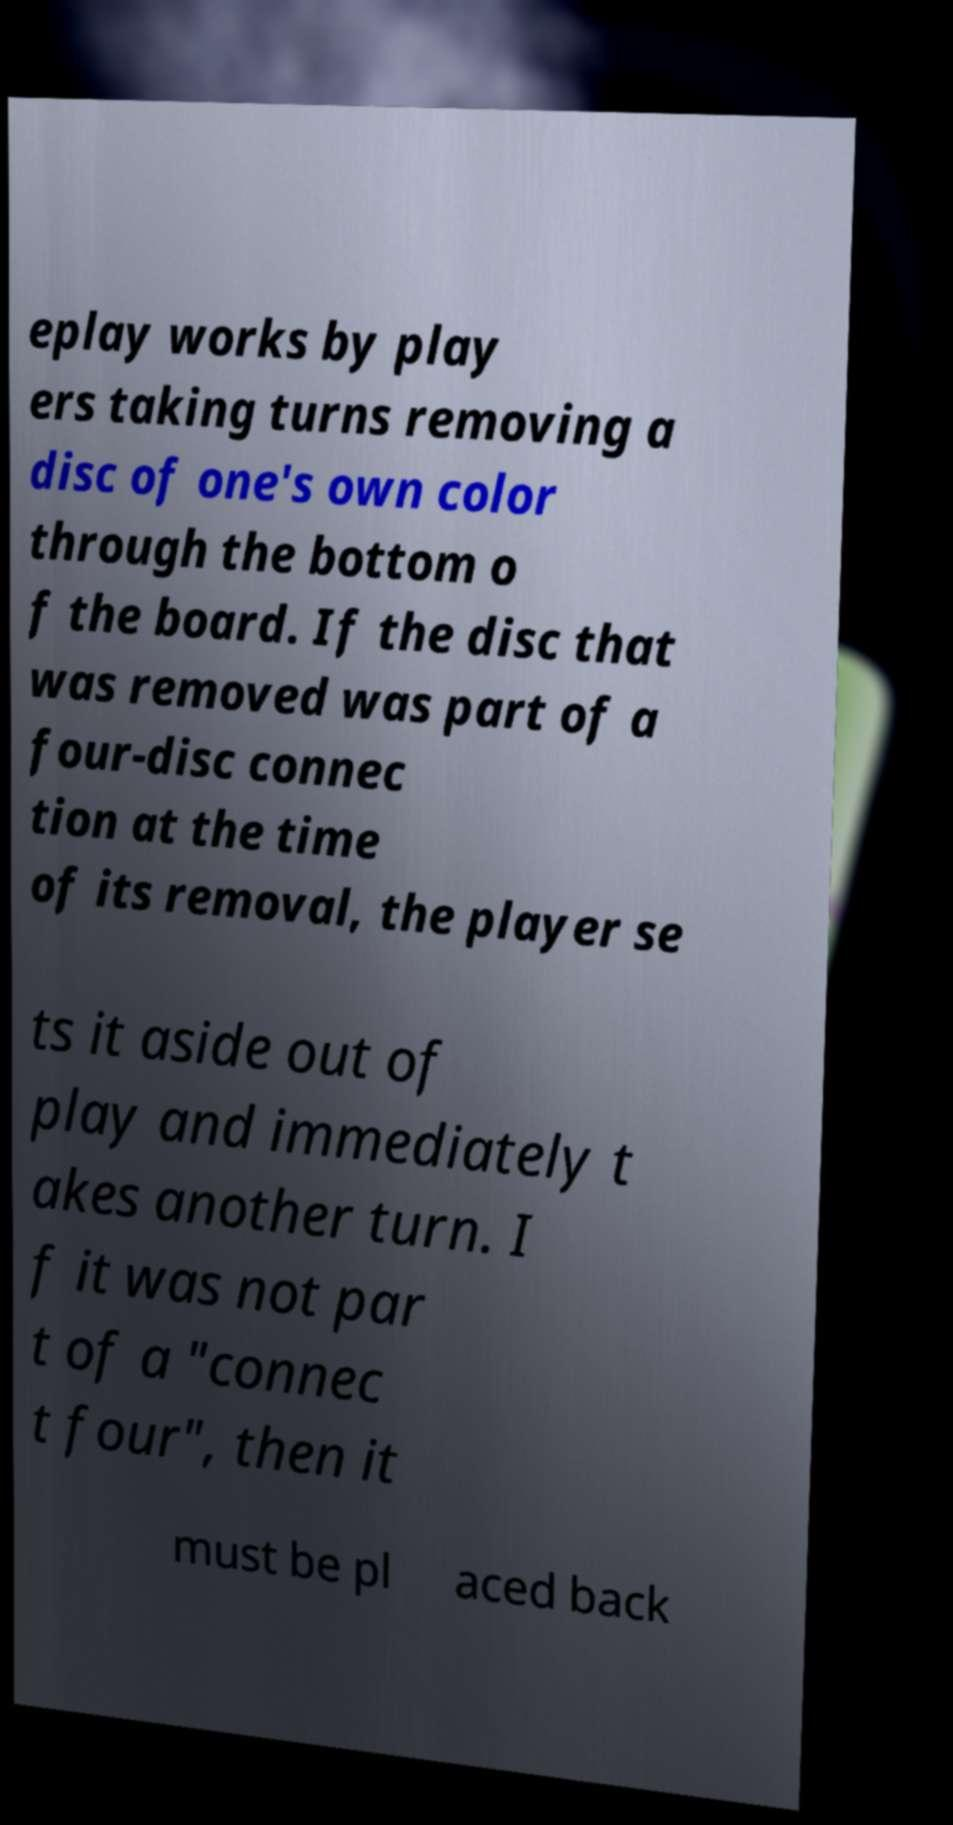I need the written content from this picture converted into text. Can you do that? eplay works by play ers taking turns removing a disc of one's own color through the bottom o f the board. If the disc that was removed was part of a four-disc connec tion at the time of its removal, the player se ts it aside out of play and immediately t akes another turn. I f it was not par t of a "connec t four", then it must be pl aced back 